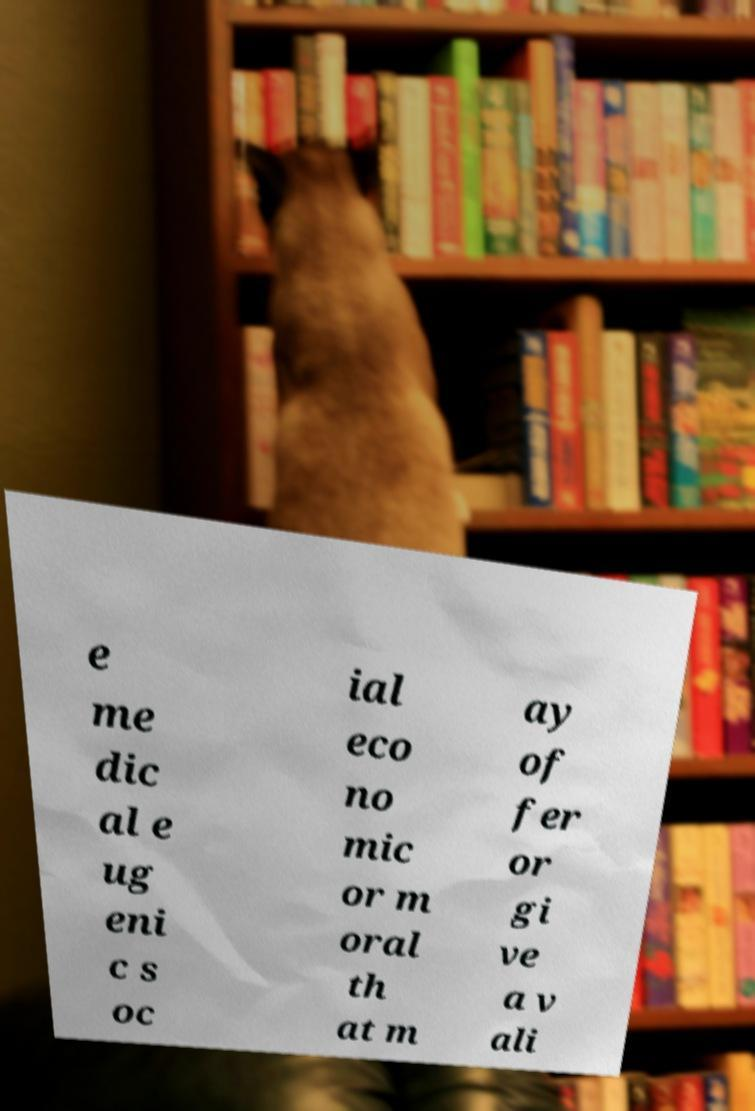Please read and relay the text visible in this image. What does it say? e me dic al e ug eni c s oc ial eco no mic or m oral th at m ay of fer or gi ve a v ali 